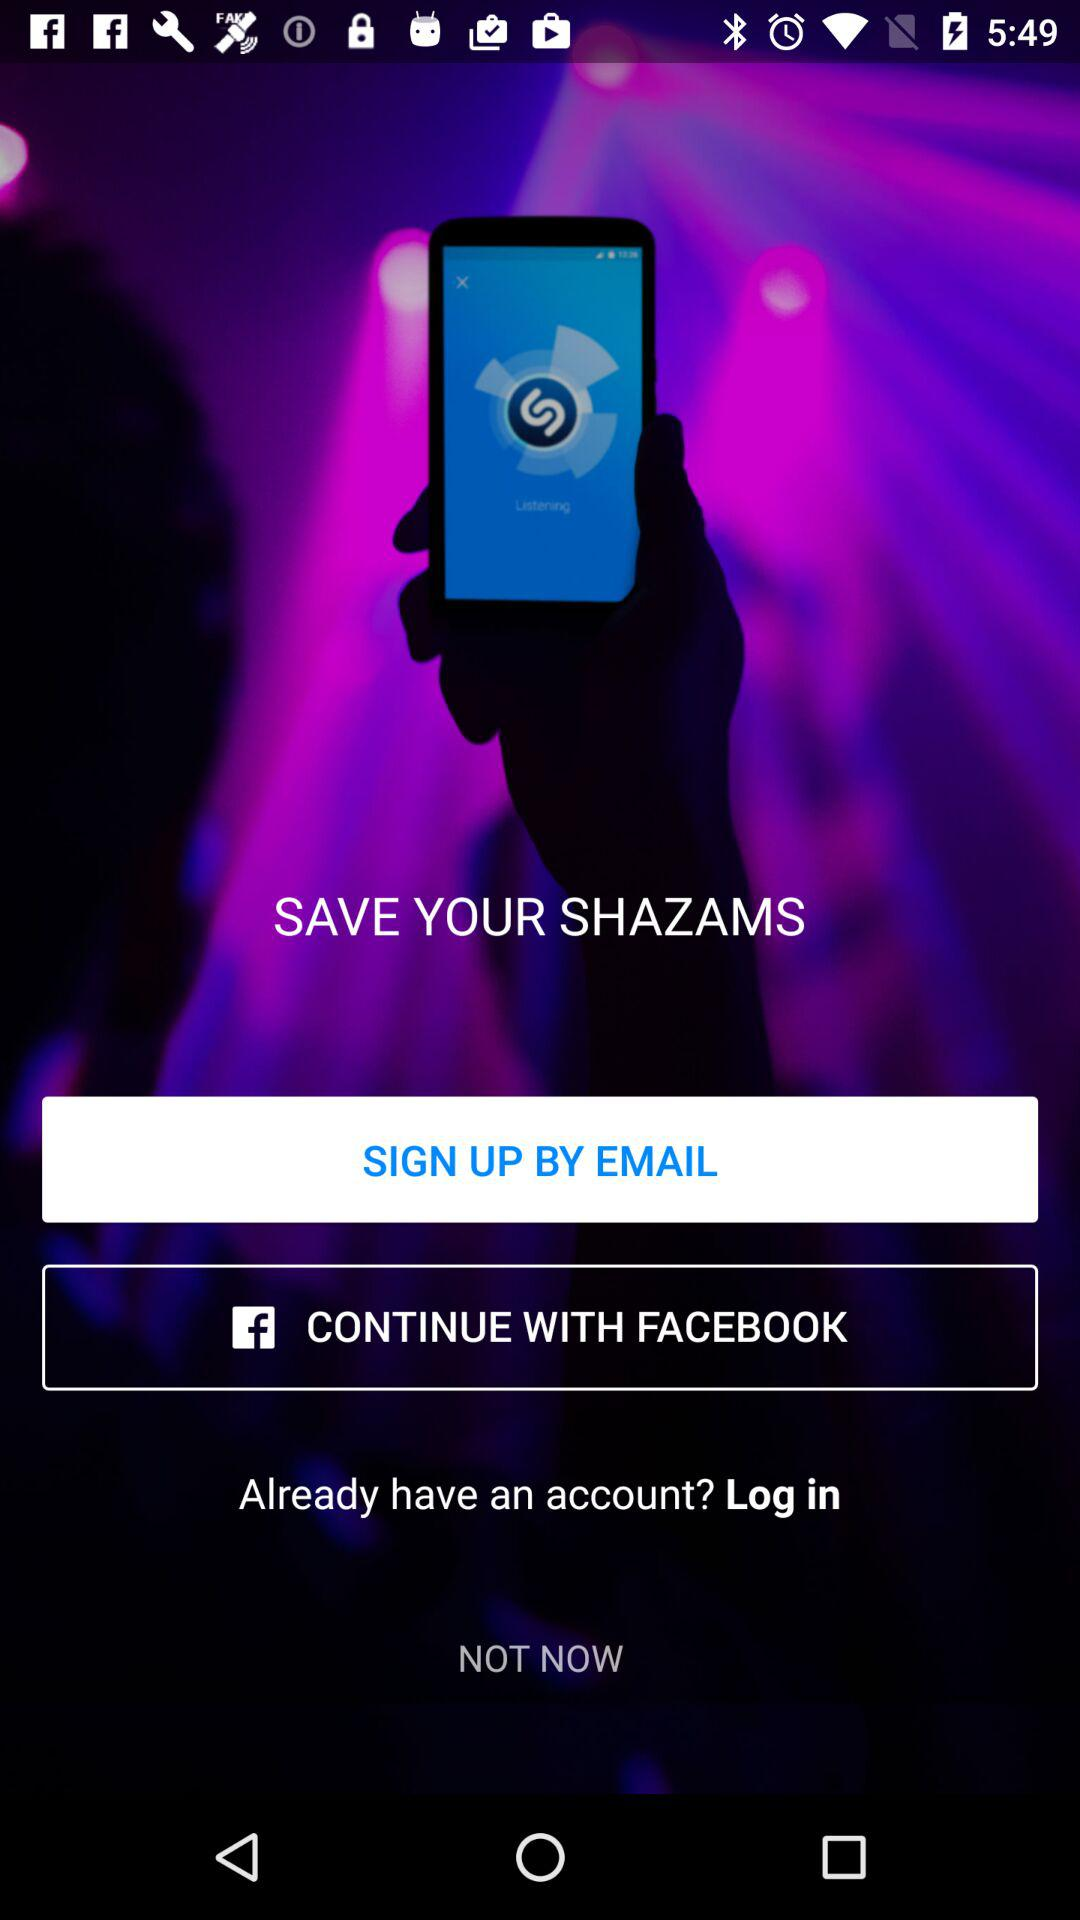How many sign up options are there?
Answer the question using a single word or phrase. 2 